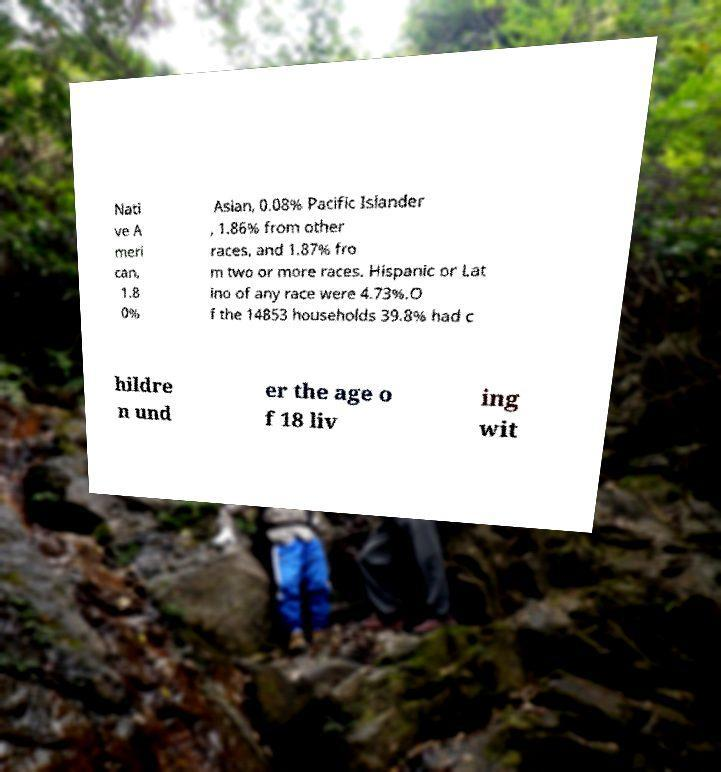Could you assist in decoding the text presented in this image and type it out clearly? Nati ve A meri can, 1.8 0% Asian, 0.08% Pacific Islander , 1.86% from other races, and 1.87% fro m two or more races. Hispanic or Lat ino of any race were 4.73%.O f the 14853 households 39.8% had c hildre n und er the age o f 18 liv ing wit 